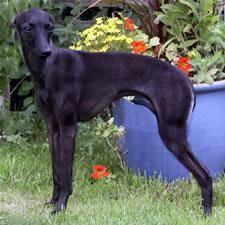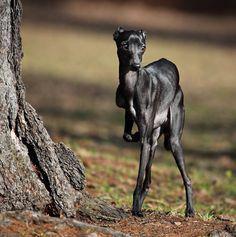The first image is the image on the left, the second image is the image on the right. Examine the images to the left and right. Is the description "There are two dogs standing and facing the same direction as the other." accurate? Answer yes or no. Yes. The first image is the image on the left, the second image is the image on the right. For the images shown, is this caption "The Italian Greyhound dog is standing in each image." true? Answer yes or no. Yes. 